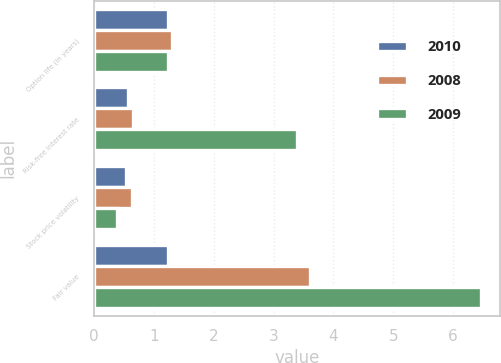Convert chart to OTSL. <chart><loc_0><loc_0><loc_500><loc_500><stacked_bar_chart><ecel><fcel>Option life (in years)<fcel>Risk-free interest rate<fcel>Stock price volatility<fcel>Fair value<nl><fcel>2010<fcel>1.24<fcel>0.57<fcel>0.53<fcel>1.24<nl><fcel>2008<fcel>1.3<fcel>0.65<fcel>0.63<fcel>3.61<nl><fcel>2009<fcel>1.24<fcel>3.4<fcel>0.38<fcel>6.47<nl></chart> 